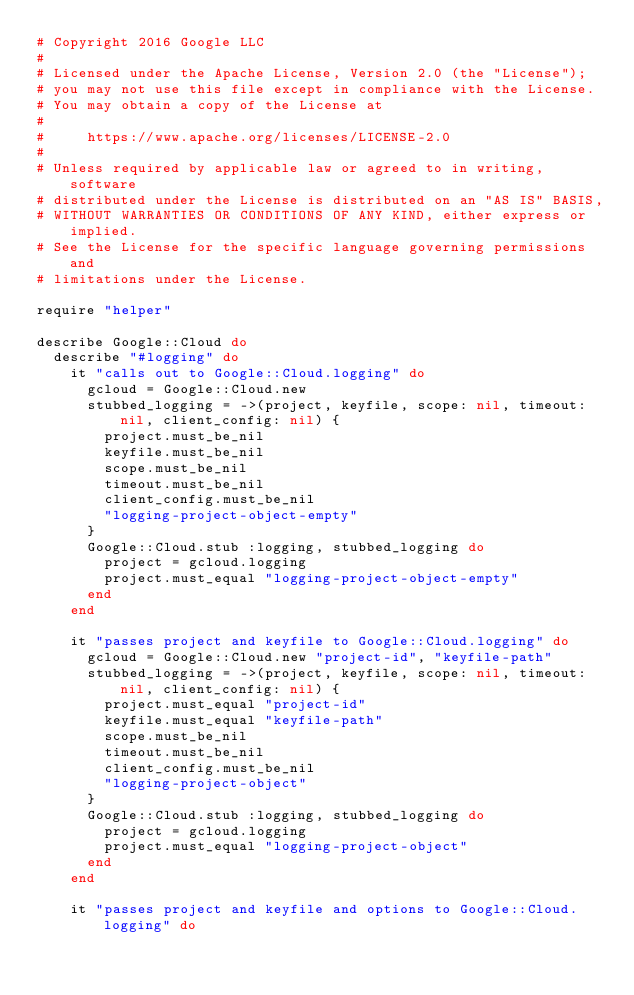Convert code to text. <code><loc_0><loc_0><loc_500><loc_500><_Ruby_># Copyright 2016 Google LLC
#
# Licensed under the Apache License, Version 2.0 (the "License");
# you may not use this file except in compliance with the License.
# You may obtain a copy of the License at
#
#     https://www.apache.org/licenses/LICENSE-2.0
#
# Unless required by applicable law or agreed to in writing, software
# distributed under the License is distributed on an "AS IS" BASIS,
# WITHOUT WARRANTIES OR CONDITIONS OF ANY KIND, either express or implied.
# See the License for the specific language governing permissions and
# limitations under the License.

require "helper"

describe Google::Cloud do
  describe "#logging" do
    it "calls out to Google::Cloud.logging" do
      gcloud = Google::Cloud.new
      stubbed_logging = ->(project, keyfile, scope: nil, timeout: nil, client_config: nil) {
        project.must_be_nil
        keyfile.must_be_nil
        scope.must_be_nil
        timeout.must_be_nil
        client_config.must_be_nil
        "logging-project-object-empty"
      }
      Google::Cloud.stub :logging, stubbed_logging do
        project = gcloud.logging
        project.must_equal "logging-project-object-empty"
      end
    end

    it "passes project and keyfile to Google::Cloud.logging" do
      gcloud = Google::Cloud.new "project-id", "keyfile-path"
      stubbed_logging = ->(project, keyfile, scope: nil, timeout: nil, client_config: nil) {
        project.must_equal "project-id"
        keyfile.must_equal "keyfile-path"
        scope.must_be_nil
        timeout.must_be_nil
        client_config.must_be_nil
        "logging-project-object"
      }
      Google::Cloud.stub :logging, stubbed_logging do
        project = gcloud.logging
        project.must_equal "logging-project-object"
      end
    end

    it "passes project and keyfile and options to Google::Cloud.logging" do</code> 